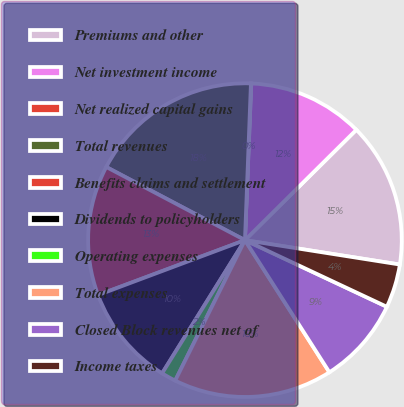Convert chart. <chart><loc_0><loc_0><loc_500><loc_500><pie_chart><fcel>Premiums and other<fcel>Net investment income<fcel>Net realized capital gains<fcel>Total revenues<fcel>Benefits claims and settlement<fcel>Dividends to policyholders<fcel>Operating expenses<fcel>Total expenses<fcel>Closed Block revenues net of<fcel>Income taxes<nl><fcel>14.91%<fcel>11.93%<fcel>0.04%<fcel>17.88%<fcel>13.42%<fcel>10.45%<fcel>1.52%<fcel>16.39%<fcel>8.96%<fcel>4.5%<nl></chart> 